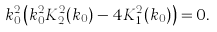<formula> <loc_0><loc_0><loc_500><loc_500>k _ { 0 } ^ { 2 } \left ( k _ { 0 } ^ { 2 } K _ { 2 } ^ { 2 } ( k _ { 0 } ) - 4 K _ { 1 } ^ { 2 } ( k _ { 0 } ) \right ) = 0 .</formula> 